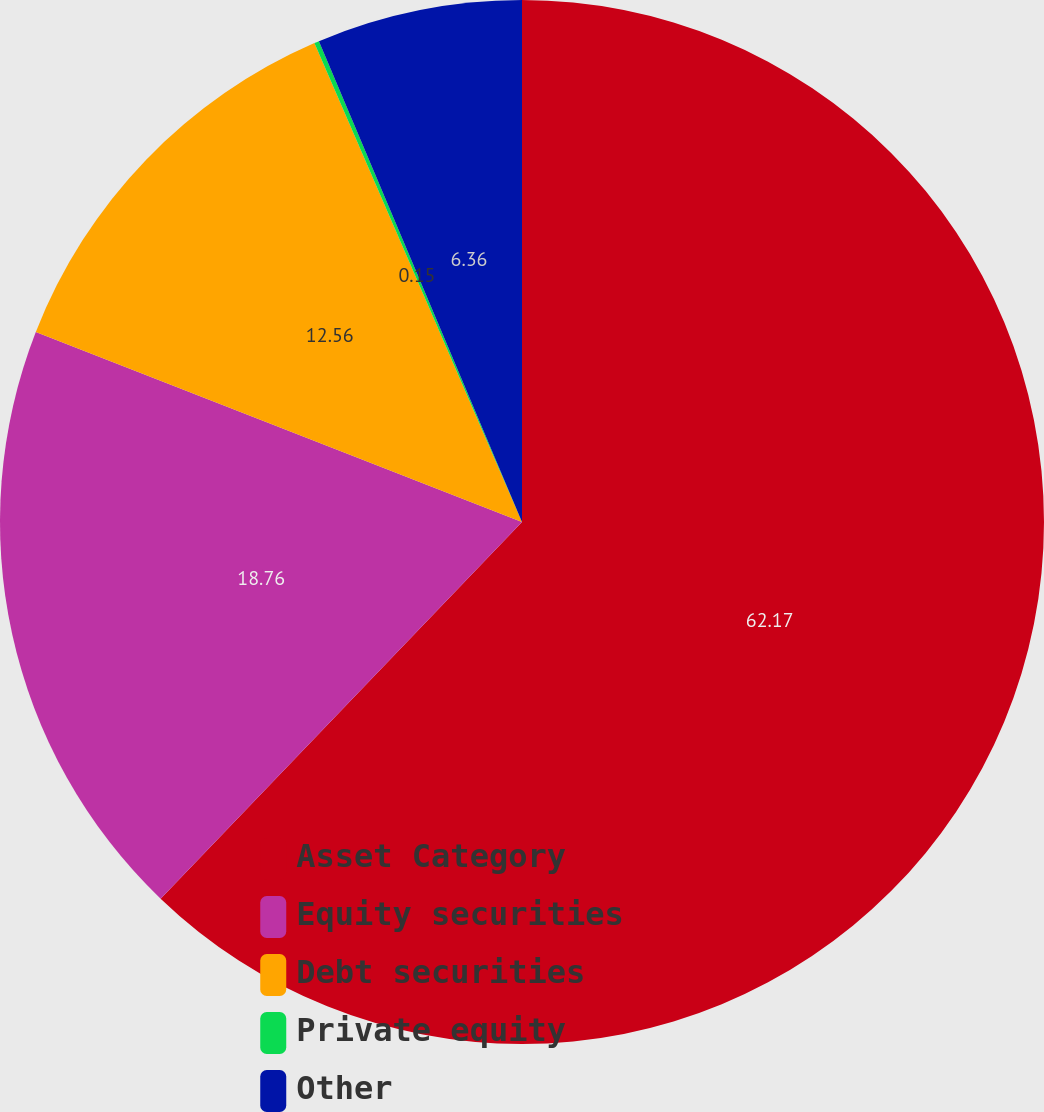Convert chart. <chart><loc_0><loc_0><loc_500><loc_500><pie_chart><fcel>Asset Category<fcel>Equity securities<fcel>Debt securities<fcel>Private equity<fcel>Other<nl><fcel>62.17%<fcel>18.76%<fcel>12.56%<fcel>0.15%<fcel>6.36%<nl></chart> 